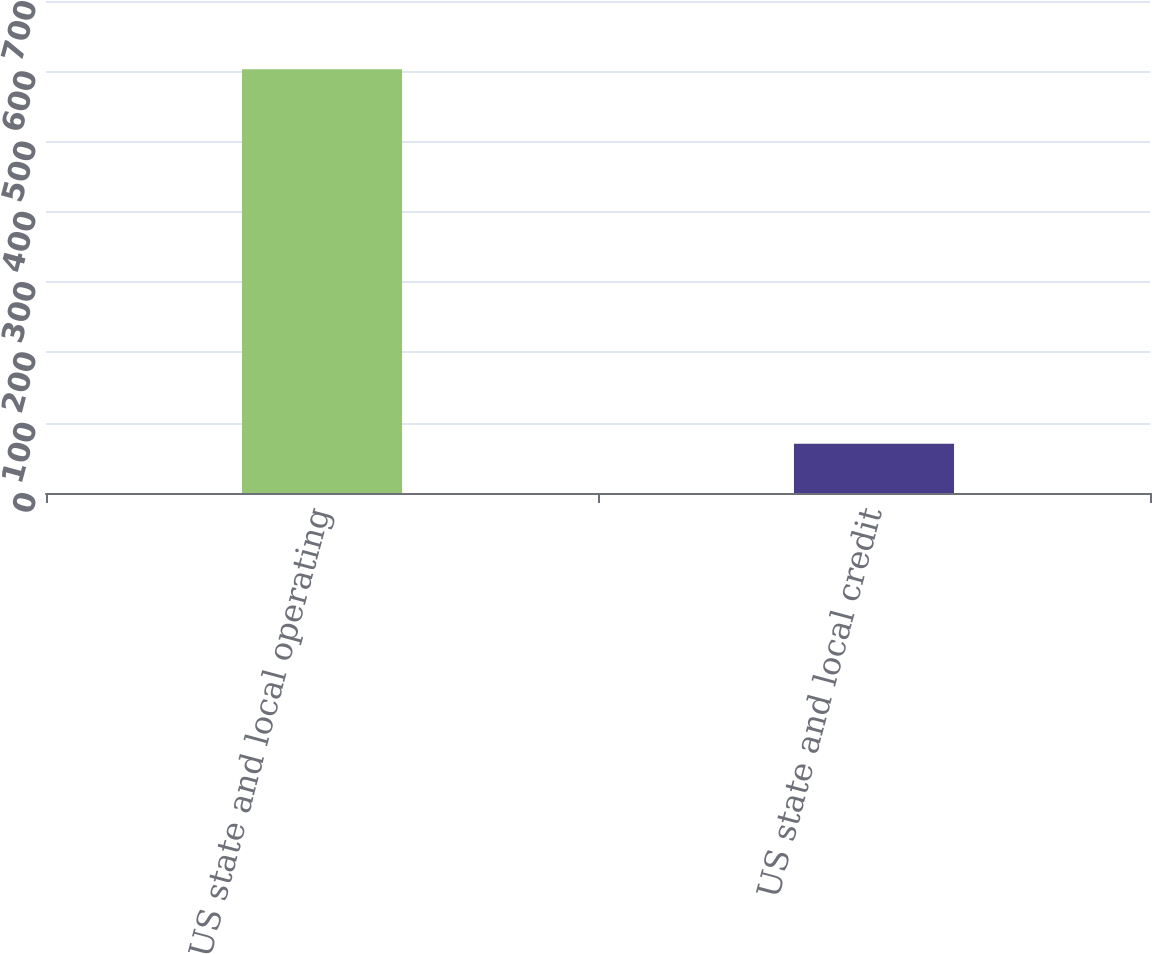Convert chart to OTSL. <chart><loc_0><loc_0><loc_500><loc_500><bar_chart><fcel>US state and local operating<fcel>US state and local credit<nl><fcel>603<fcel>70<nl></chart> 